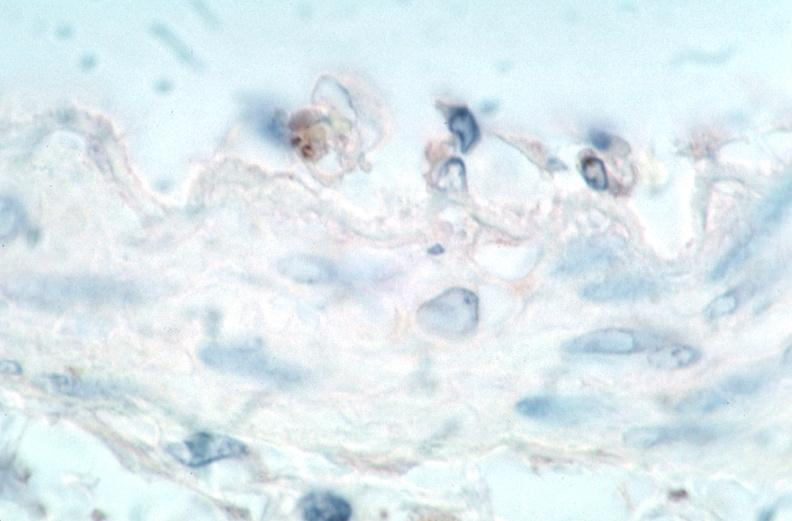what is present?
Answer the question using a single word or phrase. Vasculature 